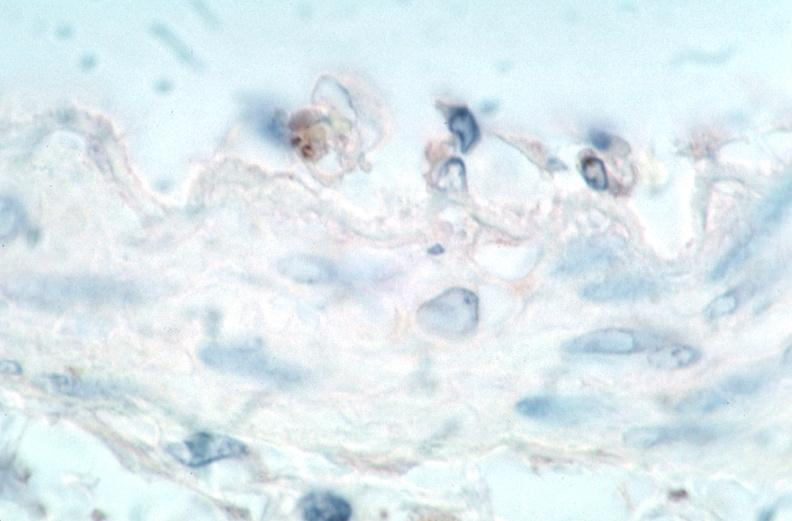what is present?
Answer the question using a single word or phrase. Vasculature 